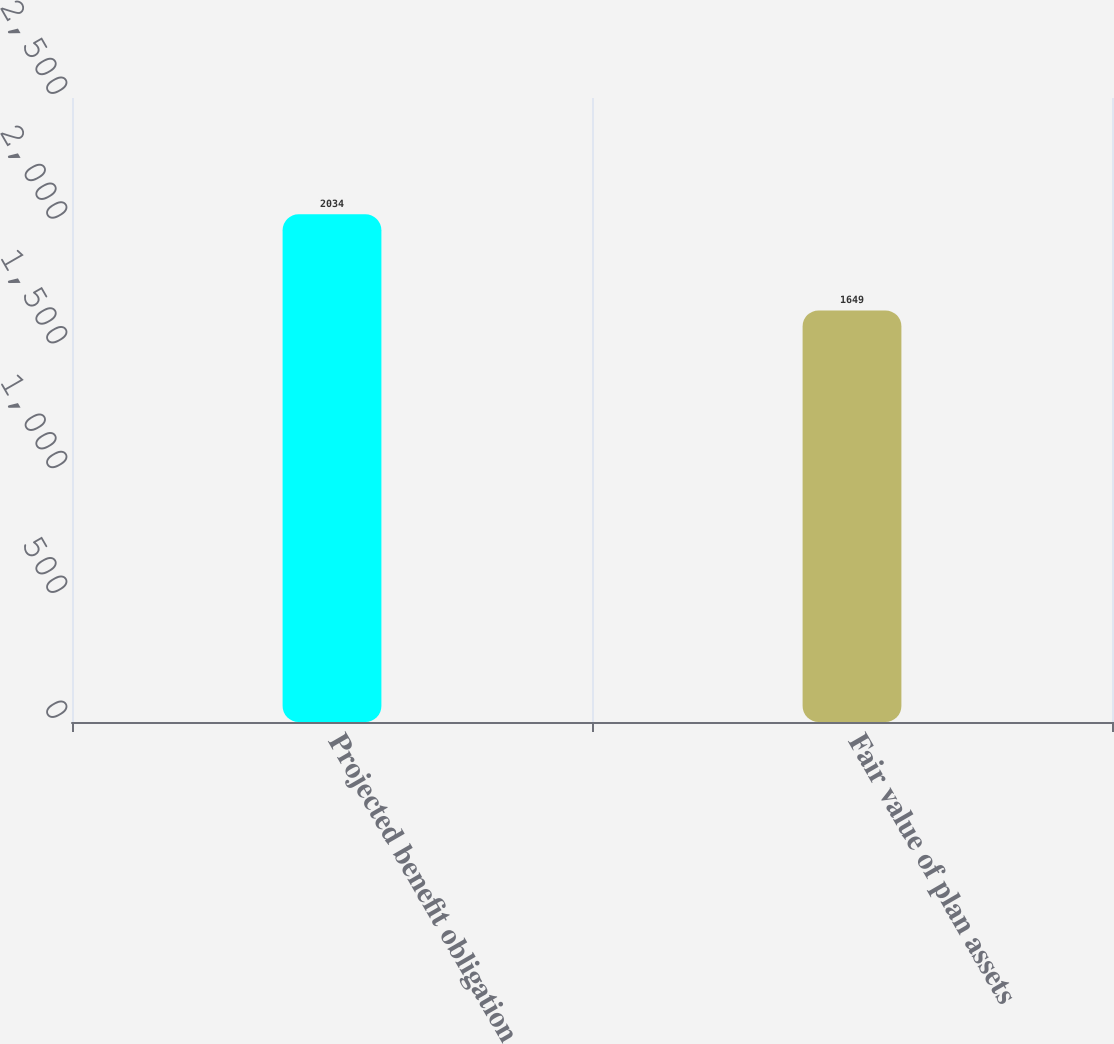<chart> <loc_0><loc_0><loc_500><loc_500><bar_chart><fcel>Projected benefit obligation<fcel>Fair value of plan assets<nl><fcel>2034<fcel>1649<nl></chart> 